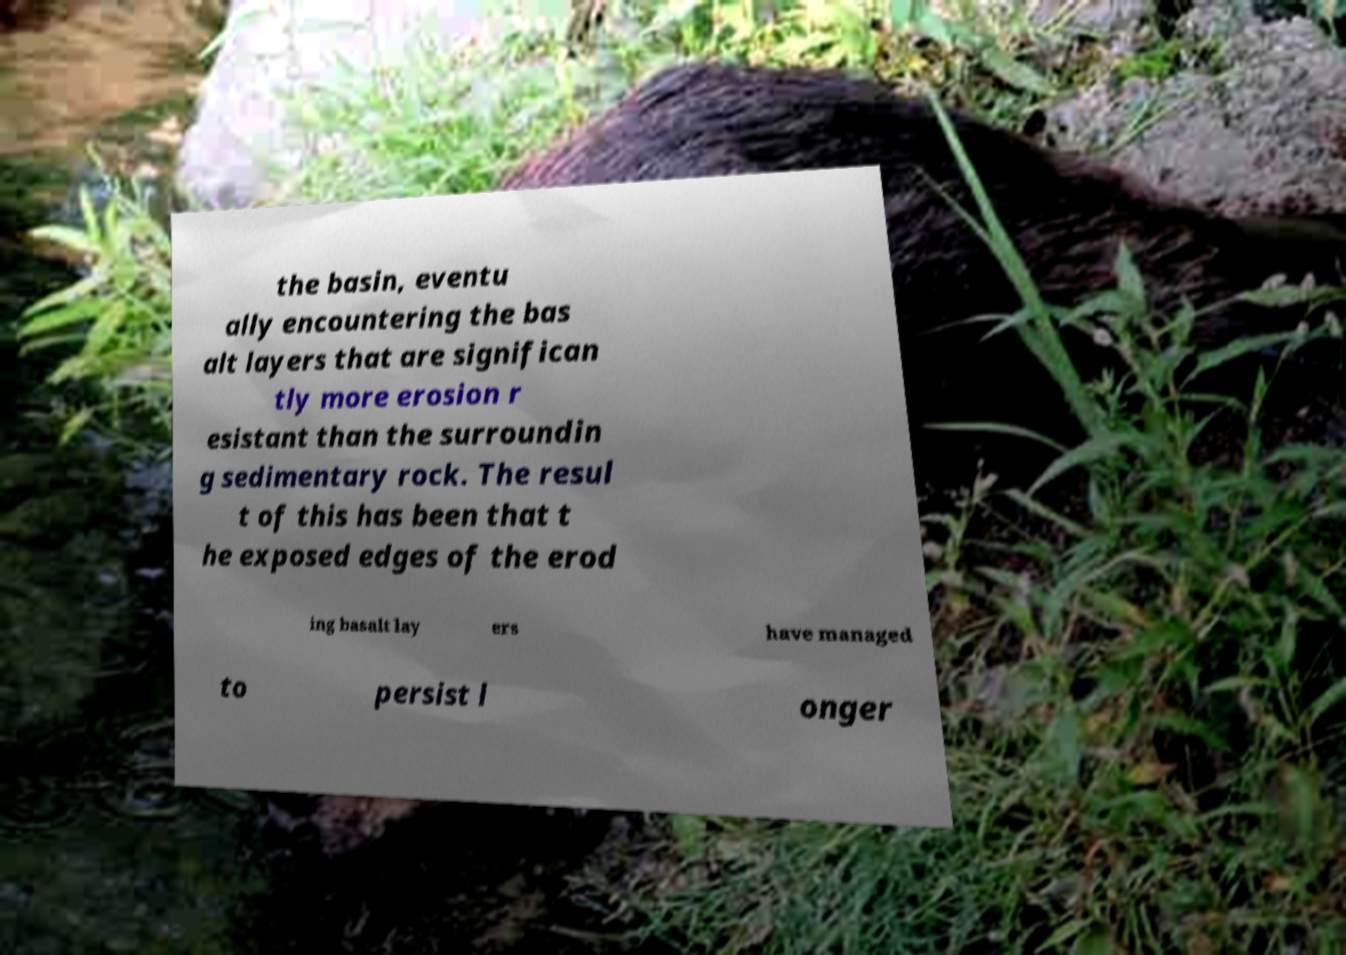Can you accurately transcribe the text from the provided image for me? the basin, eventu ally encountering the bas alt layers that are significan tly more erosion r esistant than the surroundin g sedimentary rock. The resul t of this has been that t he exposed edges of the erod ing basalt lay ers have managed to persist l onger 